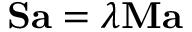<formula> <loc_0><loc_0><loc_500><loc_500>S a = \lambda M a</formula> 